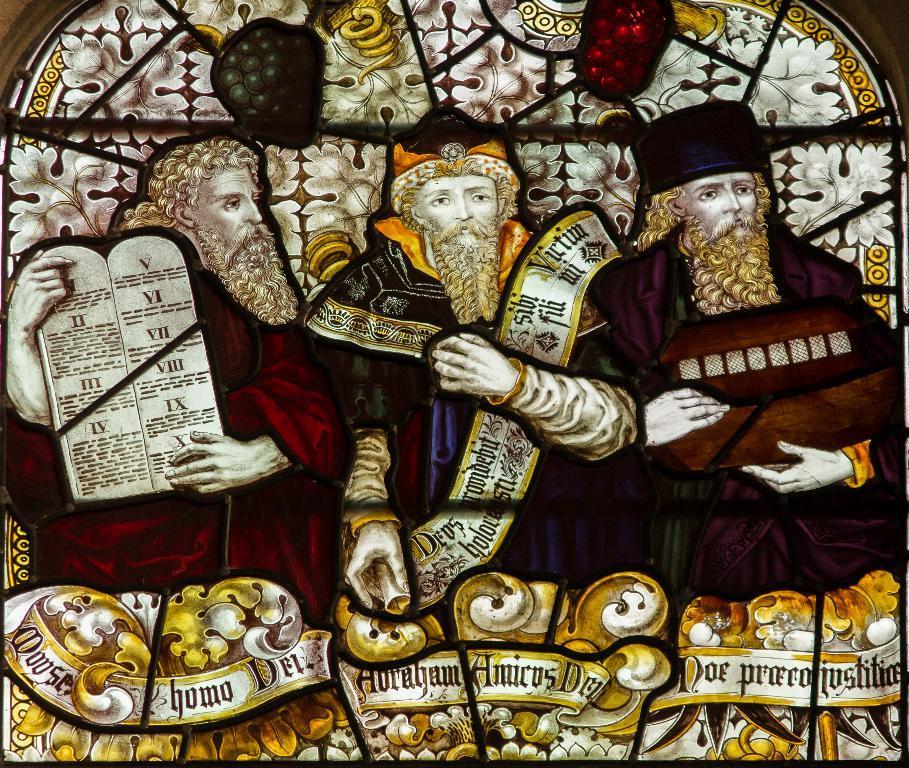Could you give a brief overview of what you see in this image? Here in this picture we can see stained glass and we can see designs of persons on the glass over there. 